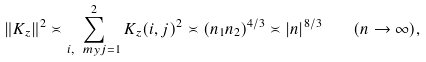<formula> <loc_0><loc_0><loc_500><loc_500>\| K _ { z } \| ^ { 2 } \asymp \sum _ { i , \ m y j = 1 } ^ { 2 } K _ { z } ( i , j ) ^ { 2 } \asymp ( n _ { 1 } n _ { 2 } ) ^ { 4 / 3 } \asymp | n | ^ { 8 / 3 } \quad ( n \to \infty ) ,</formula> 